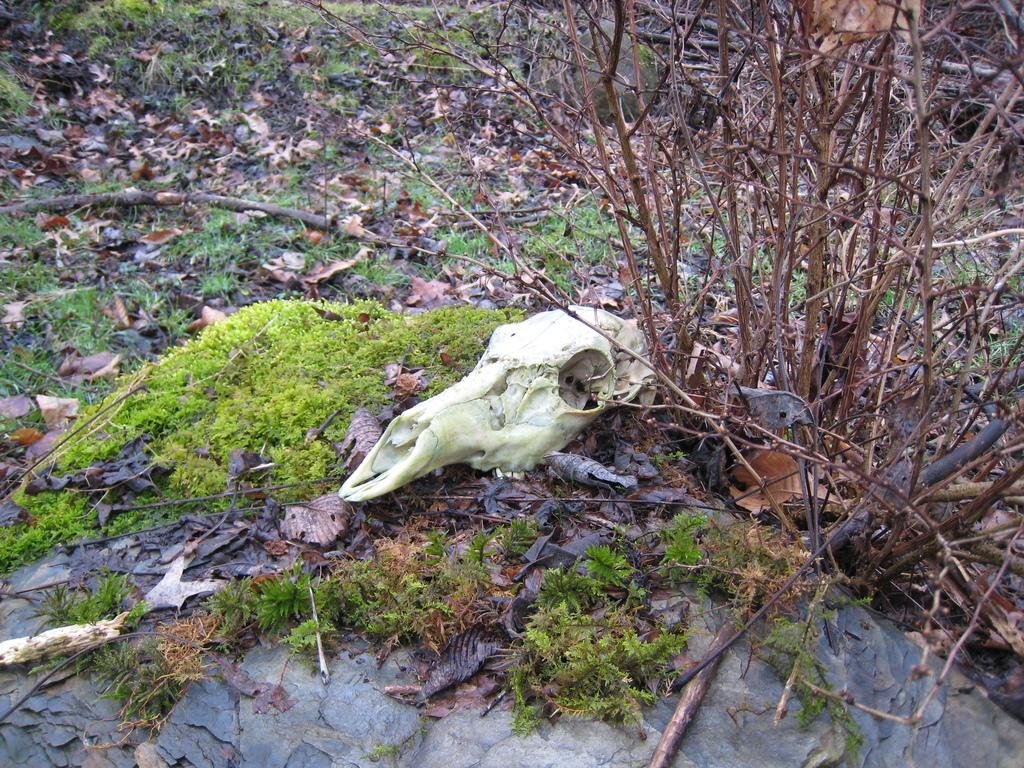What is the main subject of the image? There is a skeleton in the image. What type of natural environment is depicted in the image? There is grass visible in the image, which suggests a natural setting. What else can be seen on the ground in the image? Dried leaves are present in the image. What can be seen above the ground in the image? There are branches in the image. What type of sweater is the skeleton wearing in the image? There is no sweater present in the image, as the main subject is a skeleton, which does not wear clothing. 